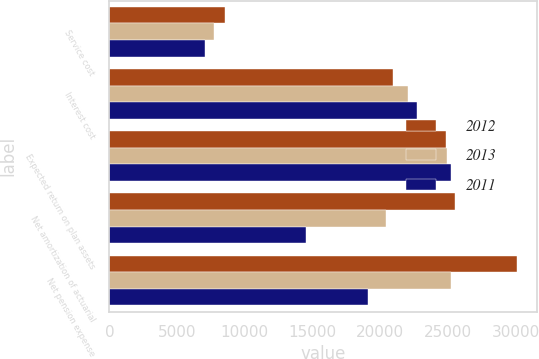Convert chart. <chart><loc_0><loc_0><loc_500><loc_500><stacked_bar_chart><ecel><fcel>Service cost<fcel>Interest cost<fcel>Expected return on plan assets<fcel>Net amortization of actuarial<fcel>Net pension expense<nl><fcel>2012<fcel>8502<fcel>20899<fcel>24828<fcel>25500<fcel>30073<nl><fcel>2013<fcel>7714<fcel>22021<fcel>24951<fcel>20454<fcel>25238<nl><fcel>2011<fcel>7073<fcel>22684<fcel>25226<fcel>14528<fcel>19059<nl></chart> 